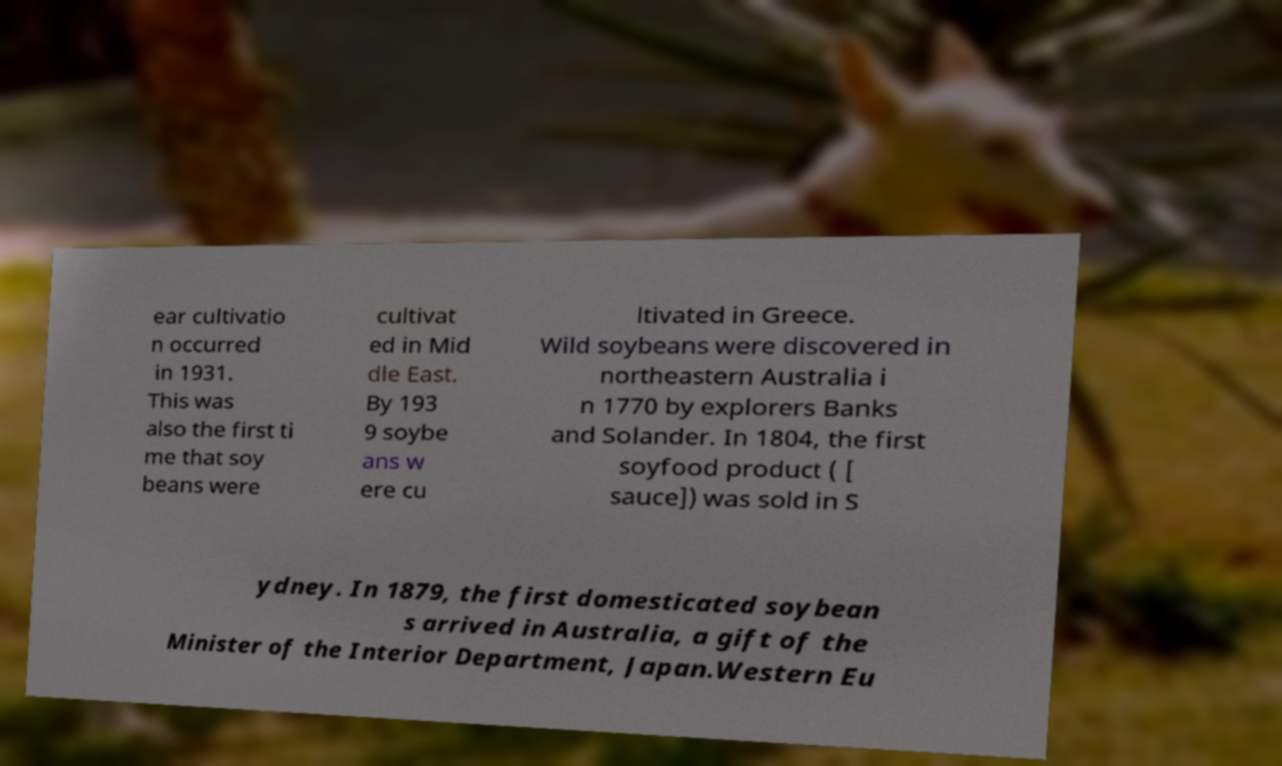I need the written content from this picture converted into text. Can you do that? ear cultivatio n occurred in 1931. This was also the first ti me that soy beans were cultivat ed in Mid dle East. By 193 9 soybe ans w ere cu ltivated in Greece. Wild soybeans were discovered in northeastern Australia i n 1770 by explorers Banks and Solander. In 1804, the first soyfood product ( [ sauce]) was sold in S ydney. In 1879, the first domesticated soybean s arrived in Australia, a gift of the Minister of the Interior Department, Japan.Western Eu 